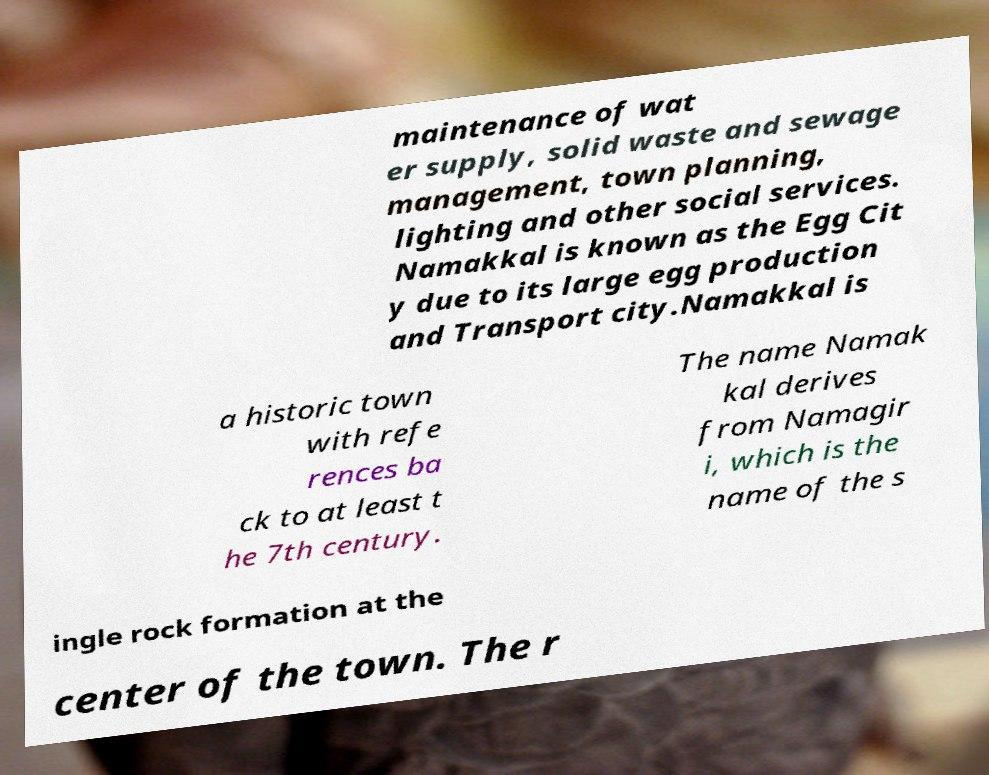I need the written content from this picture converted into text. Can you do that? maintenance of wat er supply, solid waste and sewage management, town planning, lighting and other social services. Namakkal is known as the Egg Cit y due to its large egg production and Transport city.Namakkal is a historic town with refe rences ba ck to at least t he 7th century. The name Namak kal derives from Namagir i, which is the name of the s ingle rock formation at the center of the town. The r 